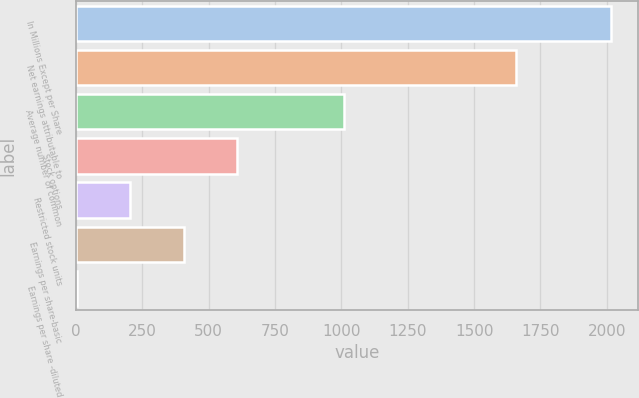Convert chart to OTSL. <chart><loc_0><loc_0><loc_500><loc_500><bar_chart><fcel>In Millions Except per Share<fcel>Net earnings attributable to<fcel>Average number of common<fcel>Stock options<fcel>Restricted stock units<fcel>Earnings per share-basic<fcel>Earnings per share -diluted<nl><fcel>2017<fcel>1657.5<fcel>1009.87<fcel>607.03<fcel>204.19<fcel>405.61<fcel>2.77<nl></chart> 